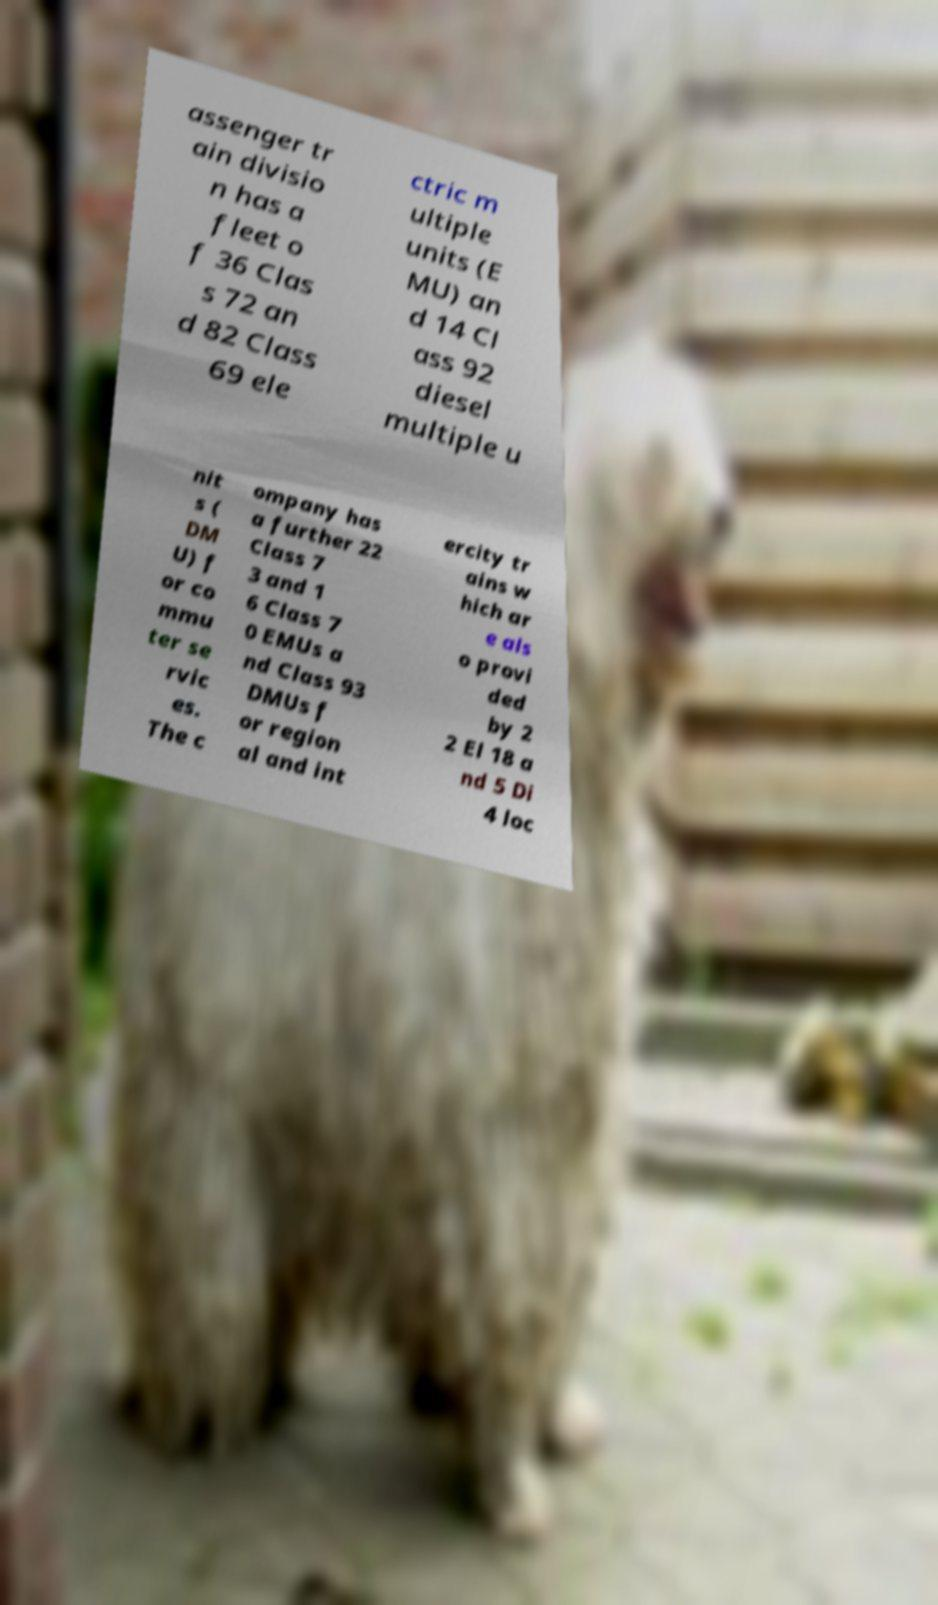Could you assist in decoding the text presented in this image and type it out clearly? assenger tr ain divisio n has a fleet o f 36 Clas s 72 an d 82 Class 69 ele ctric m ultiple units (E MU) an d 14 Cl ass 92 diesel multiple u nit s ( DM U) f or co mmu ter se rvic es. The c ompany has a further 22 Class 7 3 and 1 6 Class 7 0 EMUs a nd Class 93 DMUs f or region al and int ercity tr ains w hich ar e als o provi ded by 2 2 El 18 a nd 5 Di 4 loc 